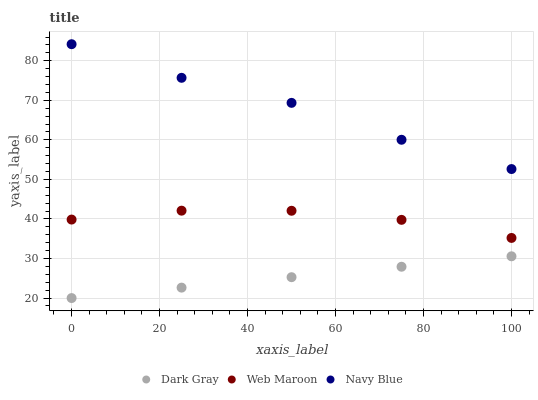Does Dark Gray have the minimum area under the curve?
Answer yes or no. Yes. Does Navy Blue have the maximum area under the curve?
Answer yes or no. Yes. Does Web Maroon have the minimum area under the curve?
Answer yes or no. No. Does Web Maroon have the maximum area under the curve?
Answer yes or no. No. Is Dark Gray the smoothest?
Answer yes or no. Yes. Is Navy Blue the roughest?
Answer yes or no. Yes. Is Web Maroon the smoothest?
Answer yes or no. No. Is Web Maroon the roughest?
Answer yes or no. No. Does Dark Gray have the lowest value?
Answer yes or no. Yes. Does Web Maroon have the lowest value?
Answer yes or no. No. Does Navy Blue have the highest value?
Answer yes or no. Yes. Does Web Maroon have the highest value?
Answer yes or no. No. Is Web Maroon less than Navy Blue?
Answer yes or no. Yes. Is Navy Blue greater than Dark Gray?
Answer yes or no. Yes. Does Web Maroon intersect Navy Blue?
Answer yes or no. No. 